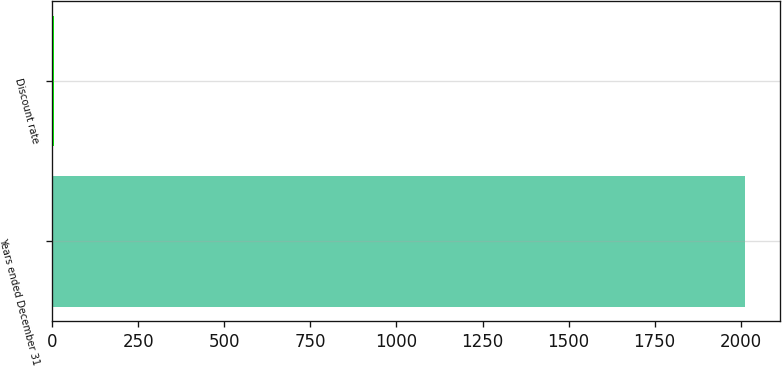Convert chart. <chart><loc_0><loc_0><loc_500><loc_500><bar_chart><fcel>Years ended December 31<fcel>Discount rate<nl><fcel>2012<fcel>5<nl></chart> 